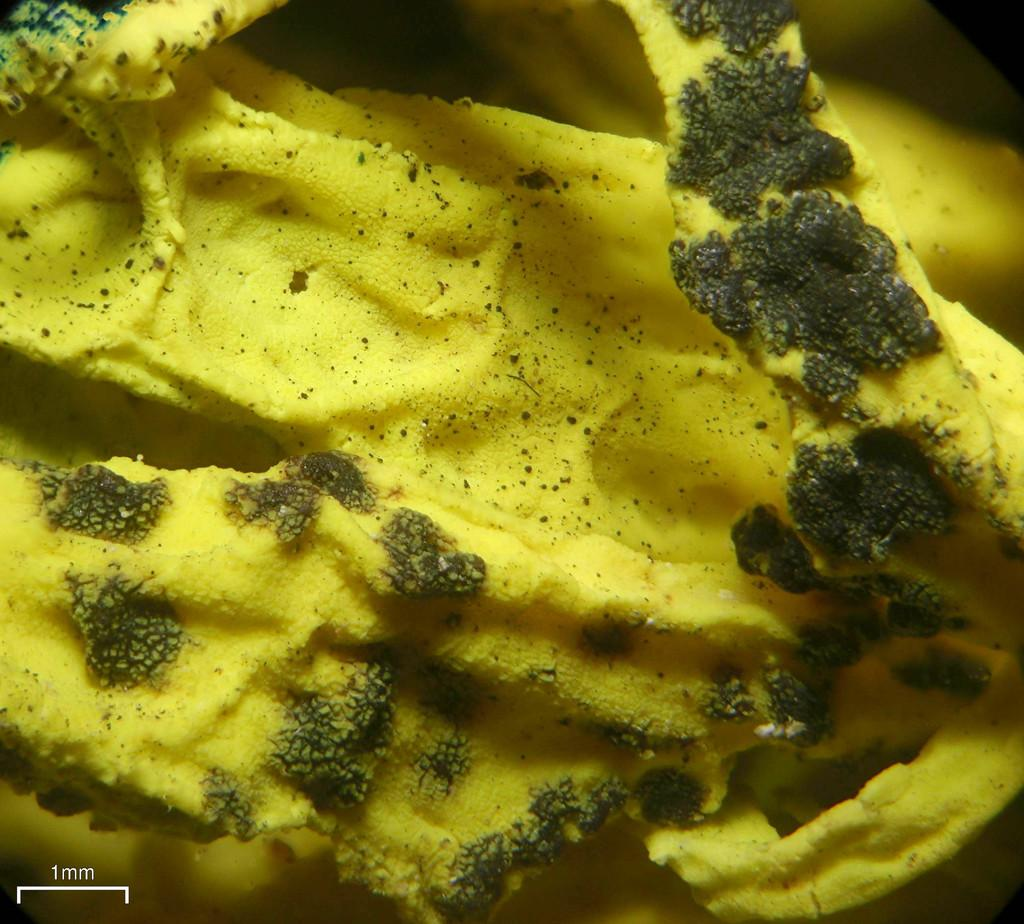What type of underwater environment is depicted in the image? There is a coral reef in the image. What might be found living in or around the coral reef? Various marine life, such as fish and sea creatures, might be found living in or around the coral reef. What is the color of the coral reef in the image? The color of the coral reef in the image may vary, as coral reefs can have a range of colors, including shades of pink, red, and brown. What type of game is being played on the coral reef in the image? There is no game being played on the coral reef in the image, as it is an underwater environment and not a location for playing games. 